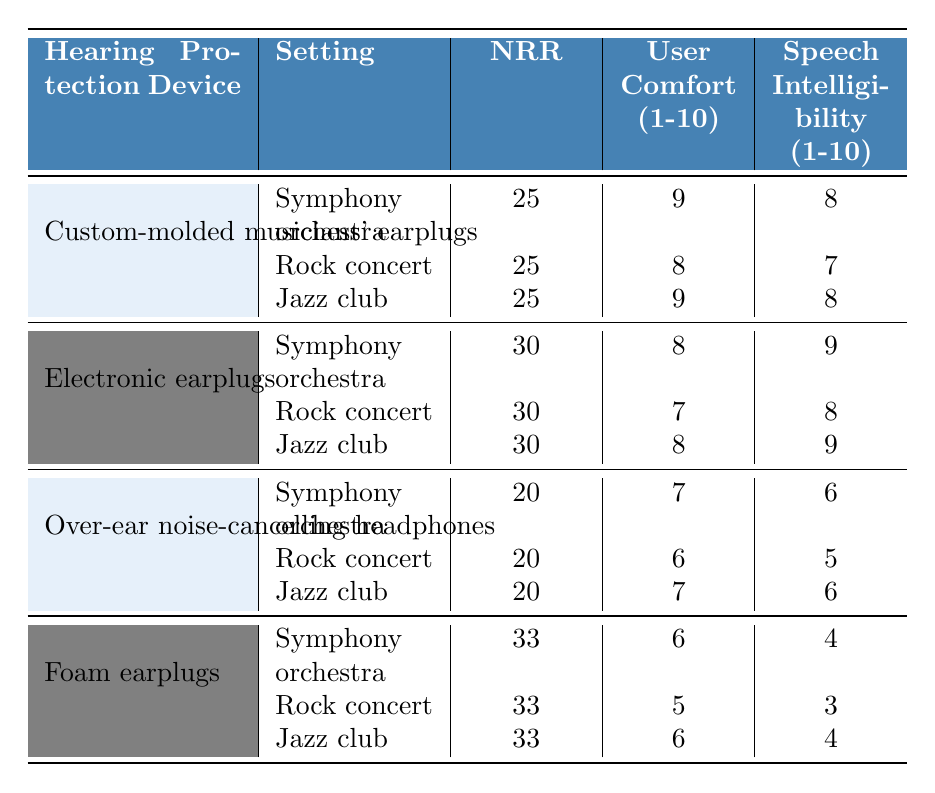What is the Noise Reduction Rating (NRR) for custom-molded musicians' earplugs in a symphony orchestra? The table shows that the NRR for custom-molded musicians' earplugs in a symphony orchestra is 25.
Answer: 25 Which hearing protection device has the highest Noise Reduction Rating (NRR) in a rock concert? The table indicates that foam earplugs have the highest NRR of 33 in a rock concert.
Answer: Foam earplugs What is the average user comfort rating for electronic earplugs across all settings? The ratings for electronic earplugs are 8, 7, and 8 for the respective settings. Summing these values gives 8 + 7 + 8 = 23, and dividing by 3 (the number of settings) yields an average of 23/3 = 7.67.
Answer: 7.67 Is the speech intelligibility rating for over-ear noise-cancelling headphones in a jazz club higher than that for foam earplugs in the same setting? The speech intelligibility rating for over-ear noise-cancelling headphones in a jazz club is 6, while for foam earplugs in the same setting, it is 4. Since 6 is greater than 4, the statement is true.
Answer: Yes Which hearing protection device has the lowest user comfort score in a rock concert? The user comfort score in a rock concert for foam earplugs is 5, which is lower than the scores for the other devices (Custom-molded: 8, Electronic: 7, Over-ear headphones: 6).
Answer: Foam earplugs What is the total user comfort rating for custom-molded musicians' earplugs in all settings? The user comfort ratings for custom-molded musicians' earplugs in the three settings are 9, 8, and 9. Summing these gives 9 + 8 + 9 = 26.
Answer: 26 Is the NRR for electronic earplugs higher than that for over-ear noise-cancelling headphones in a symphony orchestra? The NRR for electronic earplugs in a symphony orchestra is 30, while for over-ear noise-cancelling headphones, it is 20. Since 30 > 20, the statement is true.
Answer: Yes What is the difference in speech intelligibility between foam earplugs and custom-molded earplugs in a jazz club? The speech intelligibility rating for foam earplugs in a jazz club is 4, while for custom-molded earplugs it is 8. The difference is 8 - 4 = 4.
Answer: 4 In which setting do electronic earplugs and custom-molded musicians' earplugs have the same NRR? Both electronic earplugs and custom-molded musicians' earplugs have an NRR of 25 in a rock concert, so they are the same in that setting.
Answer: Rock concert What is the overall comfort score across all settings for over-ear noise-cancelling headphones? The user comfort scores are 7, 6, and 7 for the three settings, summing them gives 7 + 6 + 7 = 20.
Answer: 20 